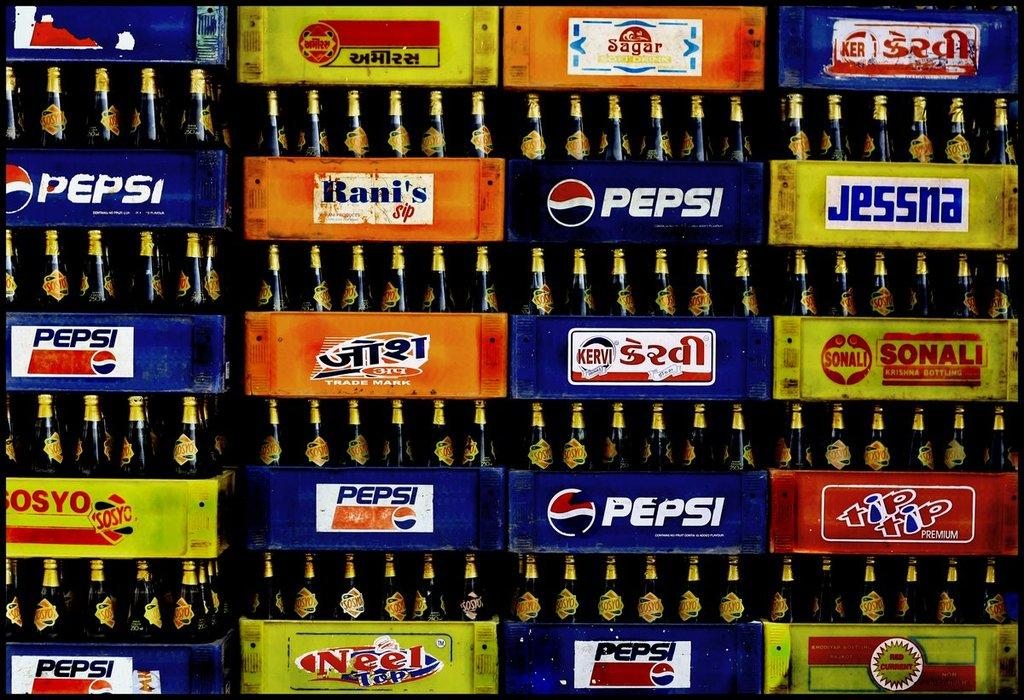<image>
Present a compact description of the photo's key features. Display of several boxes of glass sodas including Pepsi, Jessna, Neel Tap, tip tip Premium brands 